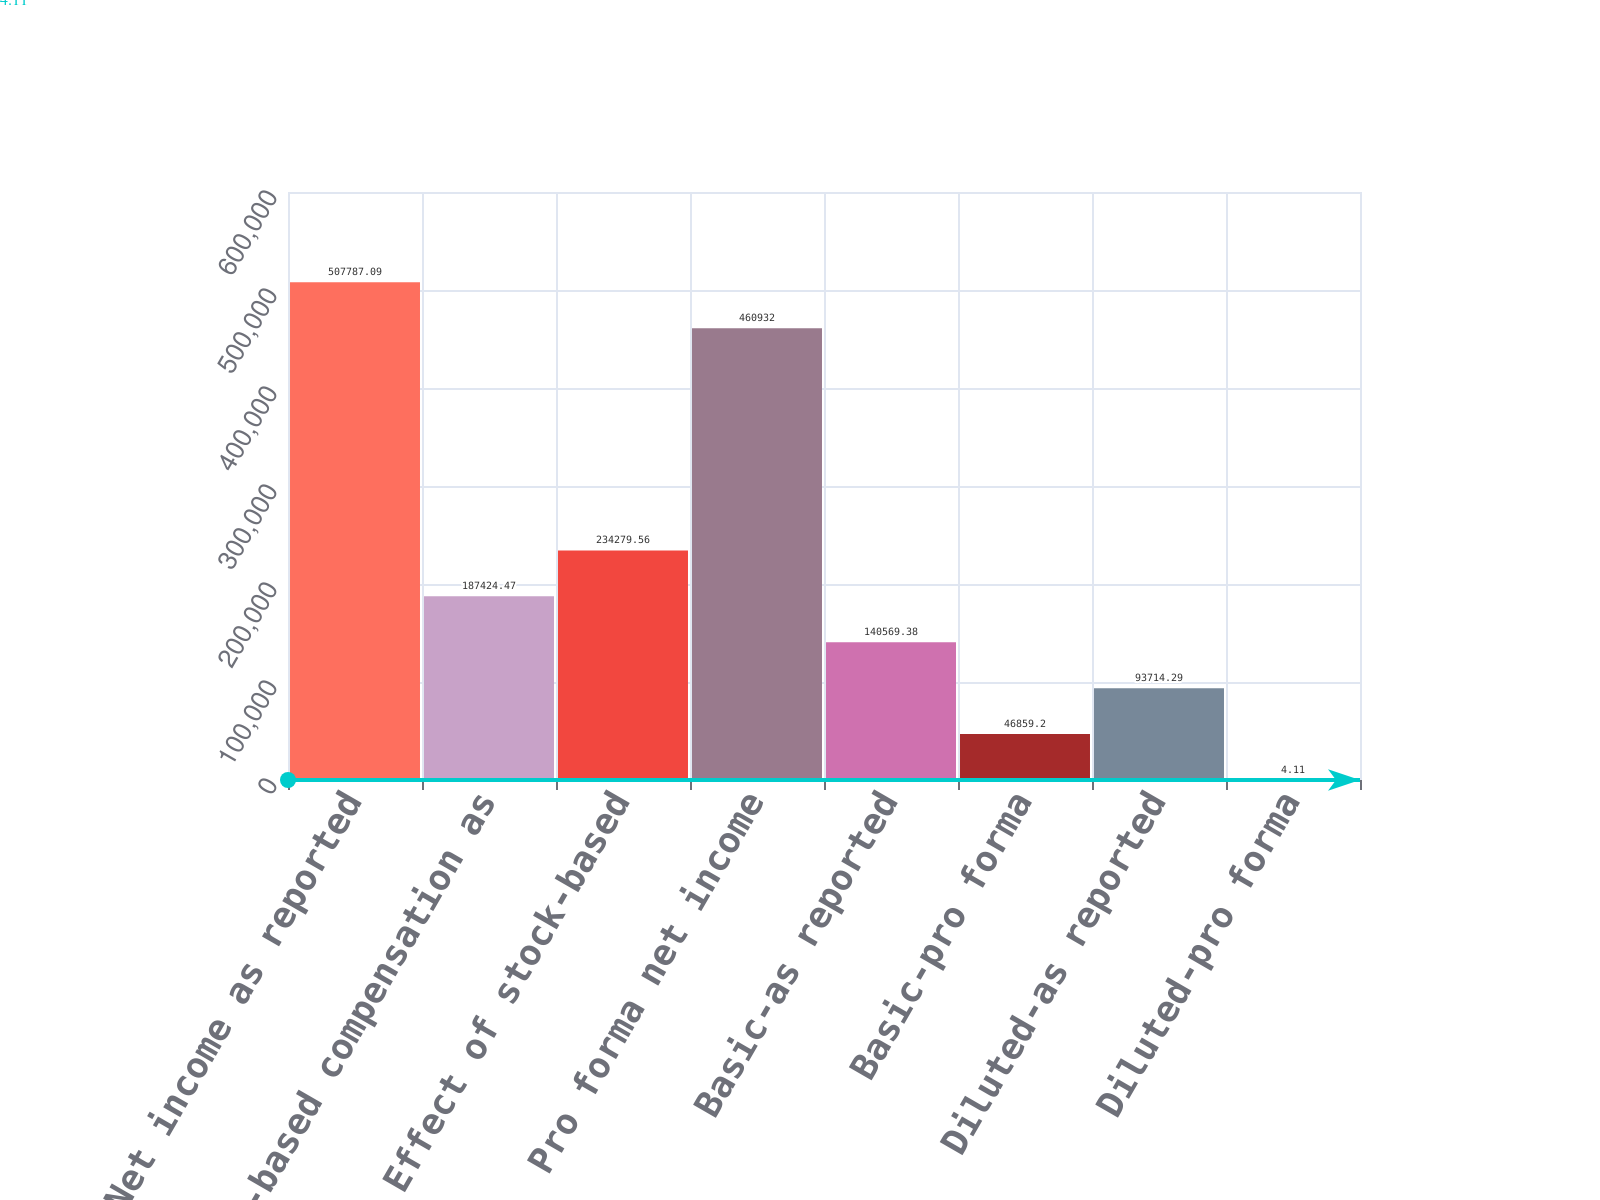Convert chart to OTSL. <chart><loc_0><loc_0><loc_500><loc_500><bar_chart><fcel>Net income as reported<fcel>Stock-based compensation as<fcel>Effect of stock-based<fcel>Pro forma net income<fcel>Basic-as reported<fcel>Basic-pro forma<fcel>Diluted-as reported<fcel>Diluted-pro forma<nl><fcel>507787<fcel>187424<fcel>234280<fcel>460932<fcel>140569<fcel>46859.2<fcel>93714.3<fcel>4.11<nl></chart> 